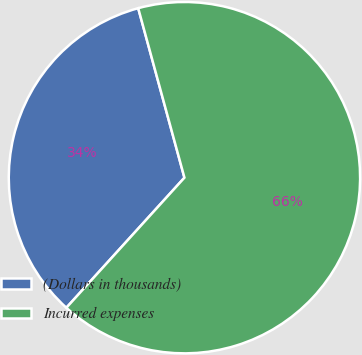Convert chart. <chart><loc_0><loc_0><loc_500><loc_500><pie_chart><fcel>(Dollars in thousands)<fcel>Incurred expenses<nl><fcel>34.03%<fcel>65.97%<nl></chart> 